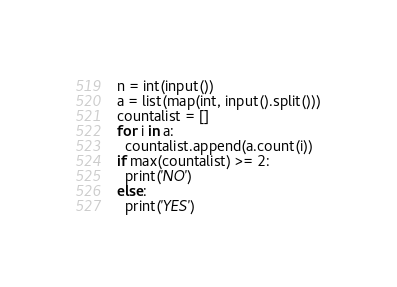Convert code to text. <code><loc_0><loc_0><loc_500><loc_500><_Python_>n = int(input())
a = list(map(int, input().split()))
countalist = []
for i in a:
  countalist.append(a.count(i))
if max(countalist) >= 2:
  print('NO')
else:
  print('YES')</code> 